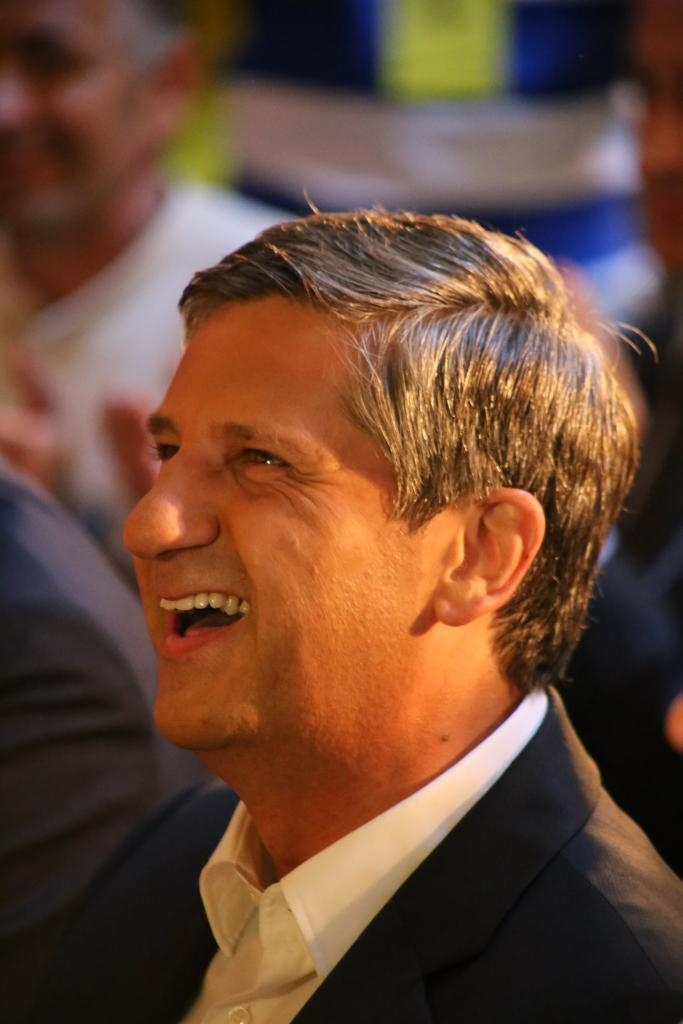What is the main subject in the foreground of the image? There is a man in the foreground of the image. What is the man wearing? The man is wearing a coat. What expression does the man have on his face? The man has a smile on his face. Can you describe the men in the background of the image? The men in the background are blurred. What type of destruction can be seen in the image? There is no destruction present in the image. --- Facts: 1. There is a car in the image. 2. The car is red. 3. The car has four wheels. 4. The car is parked on the street. Absurd Topics: unicorn, rainbow, thunderstorm Conversation: What is the main subject in the image? There is a car in the image. What color is the car? The car is red. How many wheels does the car have? The car has four wheels. Where is the car located in the image? The car is parked on the street. Reasoning: Let's think step by step in order to ${produce the conversation}. We start by identifying the main subject of the image, which is the car. Next, we describe specific features of the car, such as its color and the number of wheels it has. Then, we observe the location of the car in the image, noting that it is parked on the street. Absurd Question/Answer: How many unicorns can be seen grazing on the grass next to the red car in the image? There are no unicorns present in the image. --- Facts: 1. There is a group of people in the image. 2. The people are wearing hats. 3. The people are holding hands. 4. The people are standing in a circle formation. Absurd Topics: giant squid, underwater, submarine Conversation: How many people are in the image? There is a group of people in the image. What are the people wearing on their heads? The people are wearing hats. What are the people doing with their hands? The people are holding hands. How are the people positioned in the image? The people are standing in a circle formation. Reasoning: Let's think step by step in order to ${produce the conversation}. We start by identifying the main subjects of the image, which are the group of people. Next, we describe specific features of the people, such as their clothing and their hand-holding behavior. Then, we observe the positioning of the people in the image, noting that they are standing in a circle formation. Absurd Question/Answer: How deep underwater is the giant squid visible in the image? There is no giant squid present in the image. --- Facts: 1. There is a large tree in the image. 2. The tree has green 